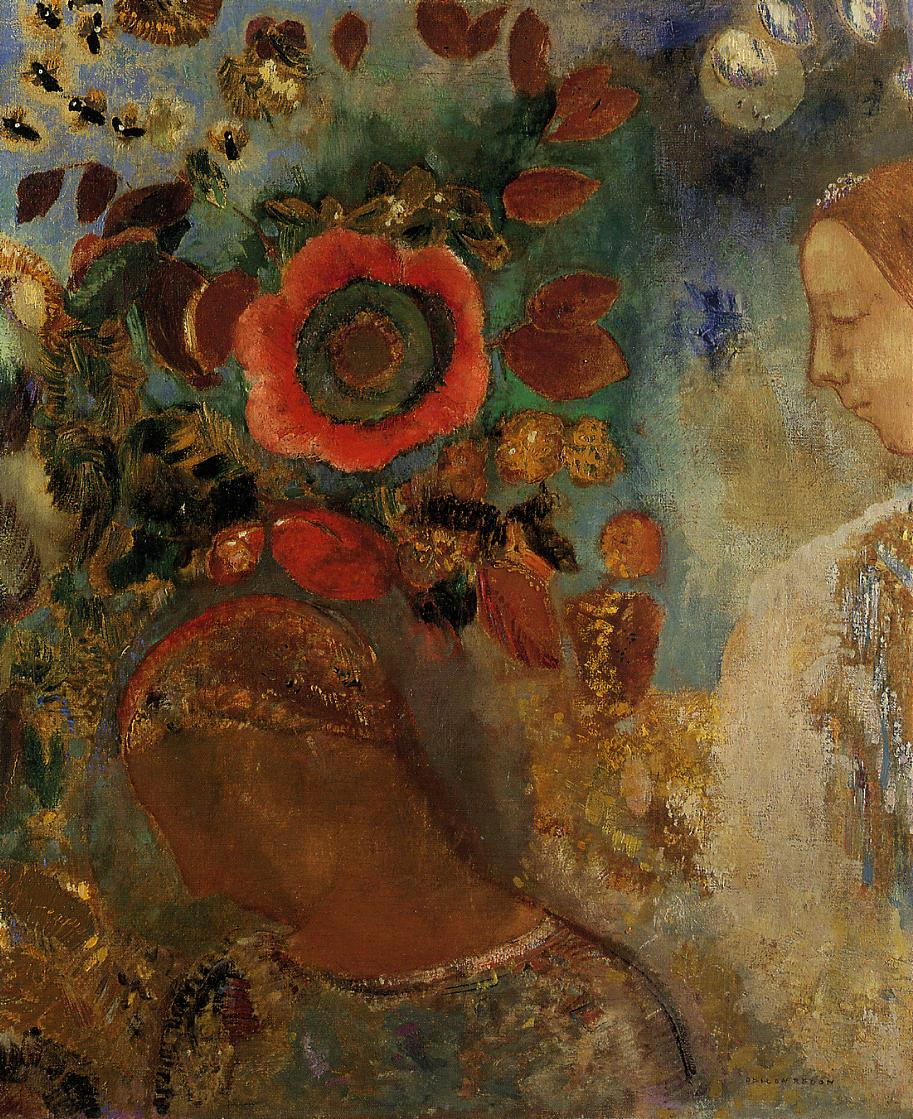Can you describe the main features of this image for me? The image portrays a woman's head and shoulders in profile, set against a vibrant backdrop of flowers and foliage. The woman's features are softly defined, capturing the essence of her form rather than the minute details. The background is a riot of color, dominated by a large red flower that seems to radiate warmth and vitality. Other flowers and foliage, rendered in hues of green and gold, create a lush tapestry that frames the woman's figure. The art style is impressionistic, characterized by loose brushstrokes that emphasize the interplay of color and light. The overall effect suggests the art genres of post-impressionism or symbolism, where the focus is on conveying an emotional or symbolic representation of the scene rather than a literal interpretation. Blue and white accents punctuate the composition, adding depth and contrast to the rich reds, greens, and golds. The image is a celebration of color and form, a testament to the artist's ability to evoke emotion through the medium of paint. 